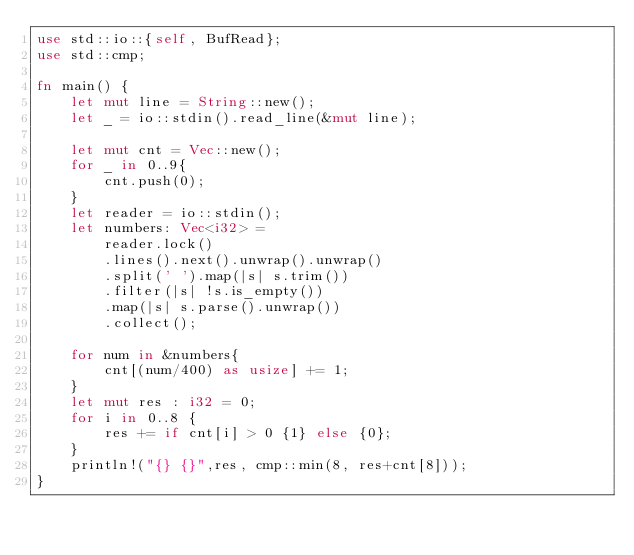<code> <loc_0><loc_0><loc_500><loc_500><_Rust_>use std::io::{self, BufRead};
use std::cmp;

fn main() {
    let mut line = String::new();
    let _ = io::stdin().read_line(&mut line);

    let mut cnt = Vec::new();
    for _ in 0..9{
        cnt.push(0);
    }
    let reader = io::stdin();
    let numbers: Vec<i32> = 
        reader.lock()       
        .lines().next().unwrap().unwrap()
        .split(' ').map(|s| s.trim())   
        .filter(|s| !s.is_empty())     
        .map(|s| s.parse().unwrap())      
        .collect();

    for num in &numbers{
        cnt[(num/400) as usize] += 1;
    }
    let mut res : i32 = 0;
    for i in 0..8 {
        res += if cnt[i] > 0 {1} else {0};
    }
    println!("{} {}",res, cmp::min(8, res+cnt[8]));
}
</code> 